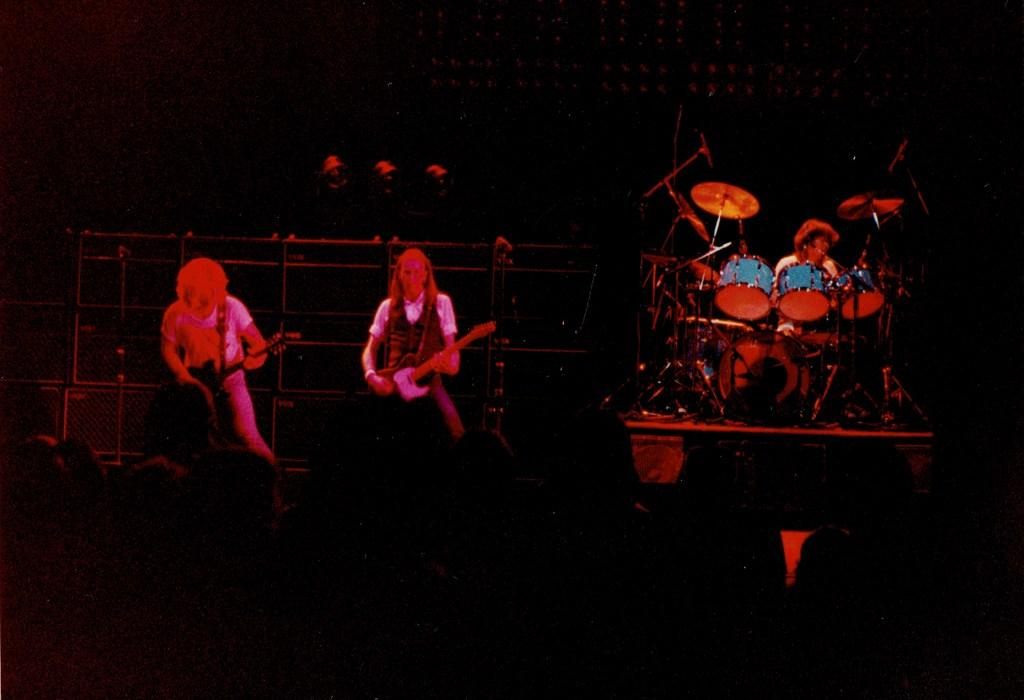Who or what is present in the image? There are people in the image. What are the people doing in the image? The people are playing musical instruments in the image. Can you describe the background of the image? The background of the image is dark. What type of fork can be seen in the image? There is no fork present in the image. What type of business is being conducted in the image? There is no indication of a business being conducted in the image; it features people playing musical instruments. How many cherries are visible in the image? There are no cherries present in the image. 